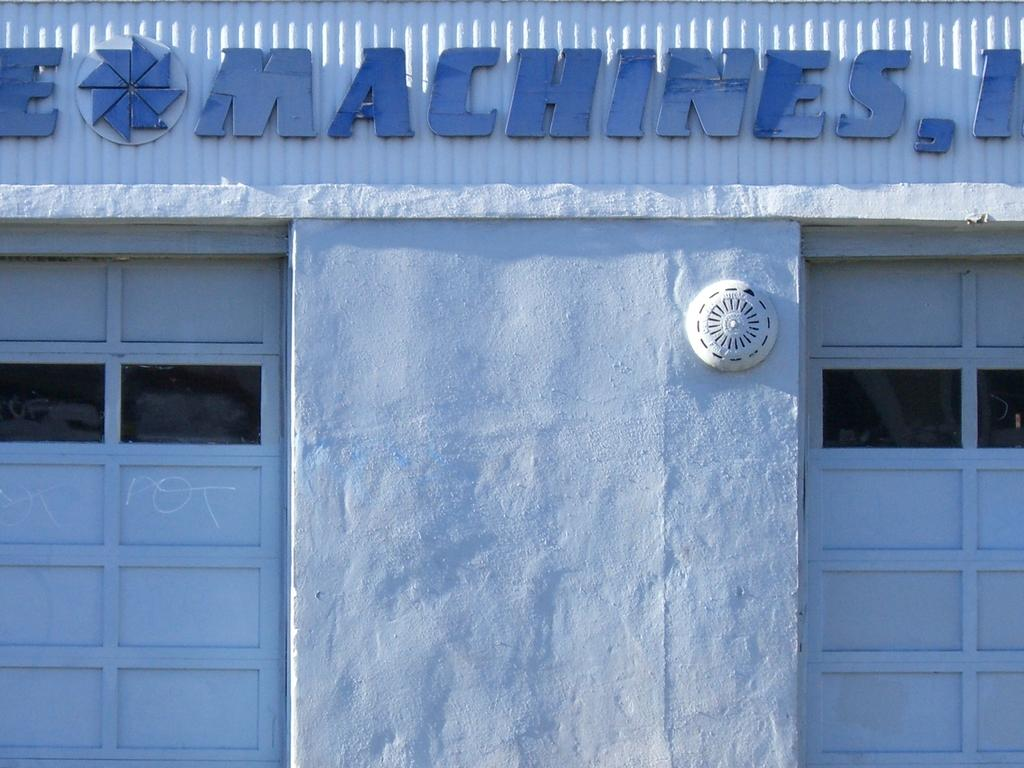What type of structure is visible in the image? There is a building in the image. What feature of the building allows people to enter or exit? There are doors in the image. Can you describe any text or symbols present on the building? There is writing on a wall in the image. What type of crate is being used to turn the building in the image? There is no crate or turning motion present in the image; it simply shows a building with doors and writing on a wall. 